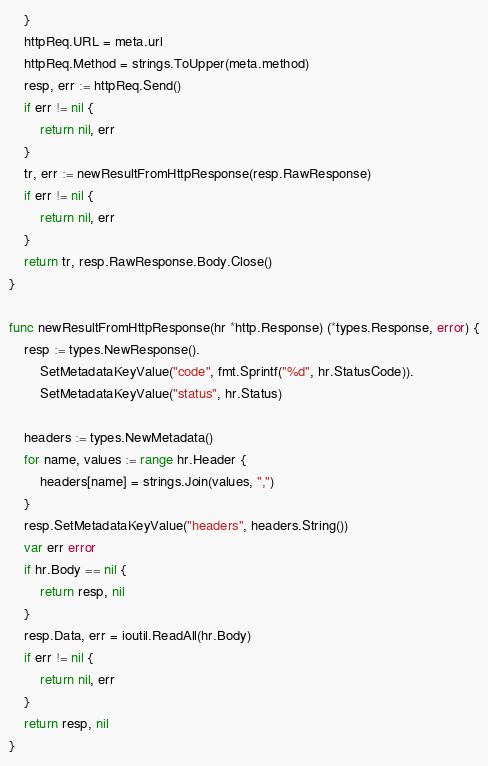Convert code to text. <code><loc_0><loc_0><loc_500><loc_500><_Go_>	}
	httpReq.URL = meta.url
	httpReq.Method = strings.ToUpper(meta.method)
	resp, err := httpReq.Send()
	if err != nil {
		return nil, err
	}
	tr, err := newResultFromHttpResponse(resp.RawResponse)
	if err != nil {
		return nil, err
	}
	return tr, resp.RawResponse.Body.Close()
}

func newResultFromHttpResponse(hr *http.Response) (*types.Response, error) {
	resp := types.NewResponse().
		SetMetadataKeyValue("code", fmt.Sprintf("%d", hr.StatusCode)).
		SetMetadataKeyValue("status", hr.Status)

	headers := types.NewMetadata()
	for name, values := range hr.Header {
		headers[name] = strings.Join(values, ",")
	}
	resp.SetMetadataKeyValue("headers", headers.String())
	var err error
	if hr.Body == nil {
		return resp, nil
	}
	resp.Data, err = ioutil.ReadAll(hr.Body)
	if err != nil {
		return nil, err
	}
	return resp, nil
}
</code> 